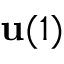Convert formula to latex. <formula><loc_0><loc_0><loc_500><loc_500>u ( 1 )</formula> 